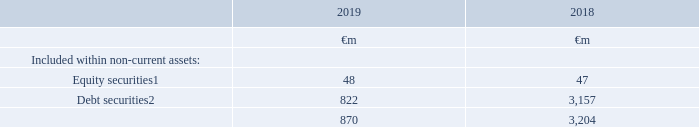13. Other investments
The Group holds a number of other listed and unlisted investments, mainly comprising managed funds, loan notes, deposits and government bonds.
Accounting policies
Other investments comprising debt and equity instruments are recognised and derecognised on a trade date where a purchase or sale of an investment is under a contract whose terms require delivery of the investment within the timeframe established by the market concerned, and are initially measured at fair value, including transaction costs.
Debt securities that are held for collection of contractual cash flows where those cash flows represent solely payments of principal and interest are measured at amortised cost using the effective interest method, less any impairment. Debt securities that do not meet the criteria for amortised cost are measured at fair value through profit and loss.
Equity securities are classified and measured at fair value through other comprehensive income, there is no subsequent reclassification of fair value gains and losses to profit or loss following derecognition of the investment. See note 1 “Basis of preparation” for previous measurement categories applicable to the comparative balances at 31 March 2018
Debt securities include loan notes of US$nil (2018: US$2.5 billion (€2.0 billion) issued by Verizon Communications Inc. as part of the Group’s disposal of its interest in Verizon Wireless all of which is recorded within non-current assets and €0.8 billion (2018: €0.9 billion) issued by VodafoneZiggo Holding B.V.
1  Items are measured at fair value and the valuation basis is level 2 classification, which comprises items where fair value is determined from inputs other than quoted prices that are observable for the asset or liability, either directly or indirectly.
2  Items are measured at amortised cost and the carrying amount approximates fair value.
What type of non-current investments are shown in the table? Equity securities, debt securities. How much is the 2019 equity securities ?
Answer scale should be: million. 48. How much is the 2018 debt securities?
Answer scale should be: million. 3,157. What is the average equity securities?
Answer scale should be: million. (48+47)/2
Answer: 47.5. What is the average debt securities?
Answer scale should be: million. (822+3,157)/2
Answer: 1989.5. What is the difference between average equity securities and average debt securities ?
Answer scale should be: million. [(822+3,157)/2] - [(48+47)/2]
Answer: 1942. 